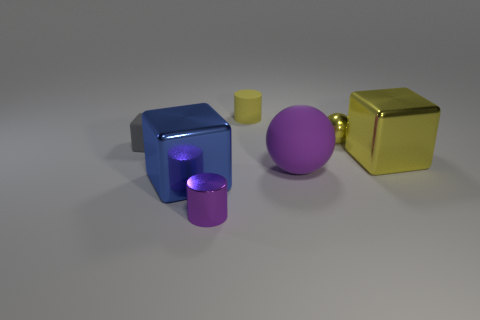Is the size of the shiny cube that is behind the blue object the same as the cylinder in front of the gray rubber thing?
Your answer should be compact. No. Is there a yellow matte cylinder that has the same size as the gray block?
Your answer should be very brief. Yes. There is a tiny object that is on the right side of the tiny yellow matte cylinder; is its shape the same as the large purple thing?
Give a very brief answer. Yes. There is a small cylinder that is in front of the big blue cube; what is it made of?
Offer a terse response. Metal. There is a large shiny object left of the tiny metal object on the left side of the tiny yellow cylinder; what is its shape?
Ensure brevity in your answer.  Cube. Is the shape of the big yellow object the same as the tiny yellow object that is in front of the tiny yellow cylinder?
Make the answer very short. No. How many purple things are on the right side of the cylinder in front of the small matte block?
Keep it short and to the point. 1. What material is the tiny gray thing that is the same shape as the blue metallic thing?
Keep it short and to the point. Rubber. What number of red objects are big cubes or big cylinders?
Your answer should be compact. 0. Is there any other thing that has the same color as the small rubber cube?
Your answer should be compact. No. 